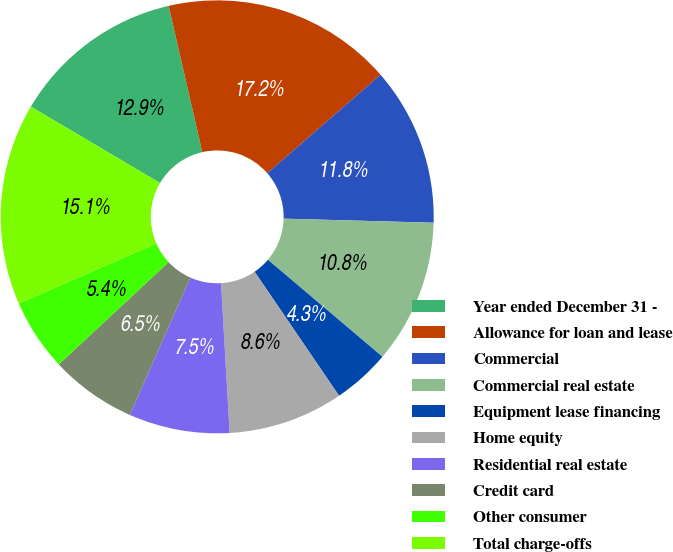<chart> <loc_0><loc_0><loc_500><loc_500><pie_chart><fcel>Year ended December 31 -<fcel>Allowance for loan and lease<fcel>Commercial<fcel>Commercial real estate<fcel>Equipment lease financing<fcel>Home equity<fcel>Residential real estate<fcel>Credit card<fcel>Other consumer<fcel>Total charge-offs<nl><fcel>12.9%<fcel>17.2%<fcel>11.83%<fcel>10.75%<fcel>4.3%<fcel>8.6%<fcel>7.53%<fcel>6.45%<fcel>5.38%<fcel>15.05%<nl></chart> 